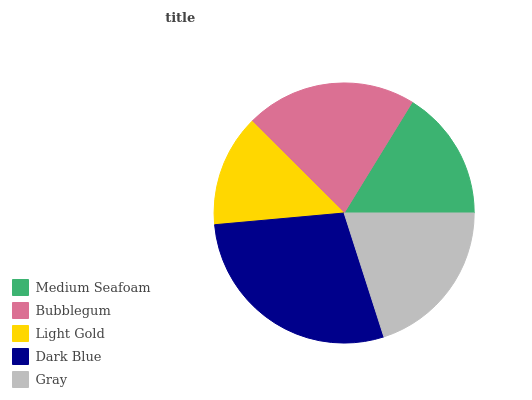Is Light Gold the minimum?
Answer yes or no. Yes. Is Dark Blue the maximum?
Answer yes or no. Yes. Is Bubblegum the minimum?
Answer yes or no. No. Is Bubblegum the maximum?
Answer yes or no. No. Is Bubblegum greater than Medium Seafoam?
Answer yes or no. Yes. Is Medium Seafoam less than Bubblegum?
Answer yes or no. Yes. Is Medium Seafoam greater than Bubblegum?
Answer yes or no. No. Is Bubblegum less than Medium Seafoam?
Answer yes or no. No. Is Gray the high median?
Answer yes or no. Yes. Is Gray the low median?
Answer yes or no. Yes. Is Medium Seafoam the high median?
Answer yes or no. No. Is Medium Seafoam the low median?
Answer yes or no. No. 